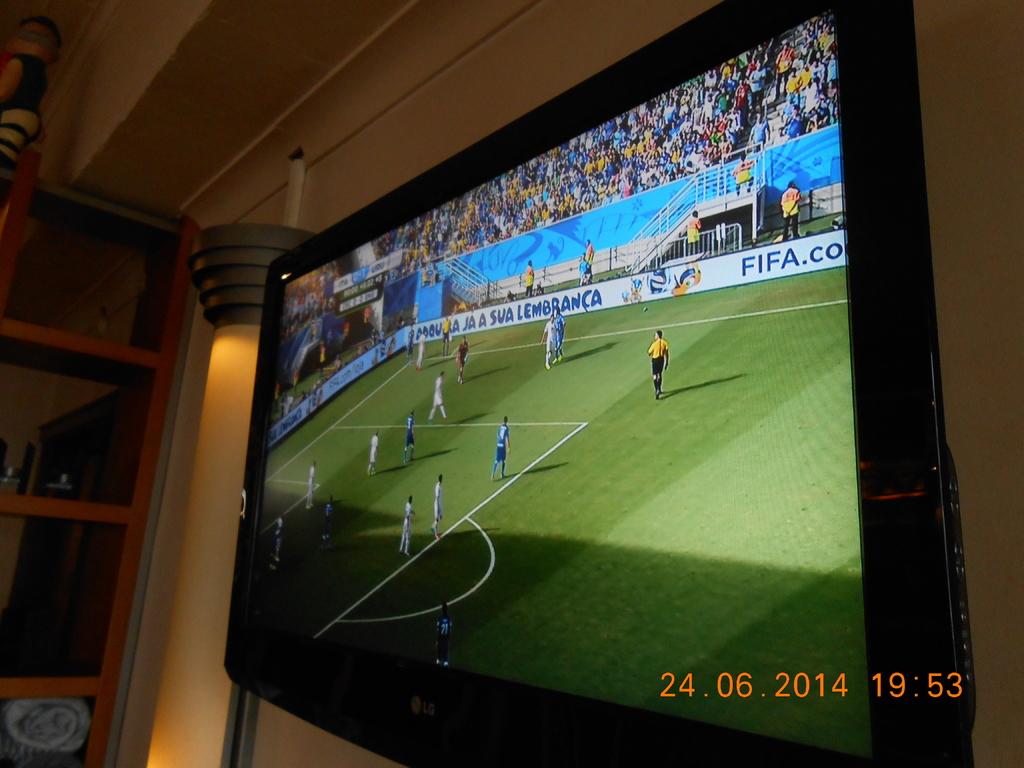What association is advertised on the wall?
Offer a very short reply. Fifa. What brand is the tv?
Your answer should be compact. Lg. 